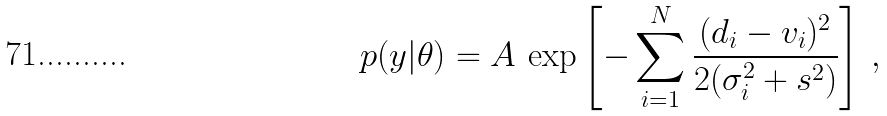<formula> <loc_0><loc_0><loc_500><loc_500>p ( y | \theta ) = A \, \exp \left [ - \sum _ { i = 1 } ^ { N } \frac { ( d _ { i } - v _ { i } ) ^ { 2 } } { 2 ( \sigma _ { i } ^ { 2 } + s ^ { 2 } ) } \right ] \, ,</formula> 